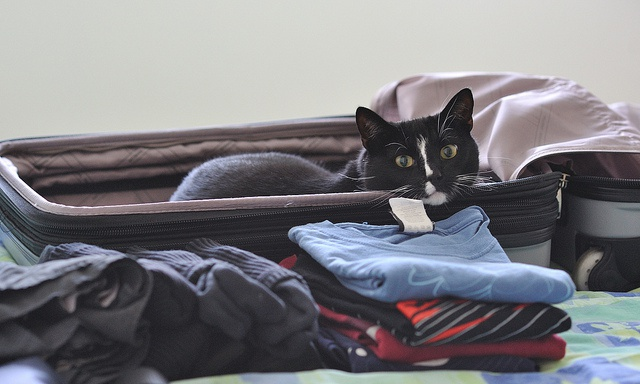Describe the objects in this image and their specific colors. I can see suitcase in lightgray, black, gray, and darkgray tones, cat in lightgray, black, gray, and darkgray tones, and bed in lightgray, darkgray, and lightblue tones in this image. 